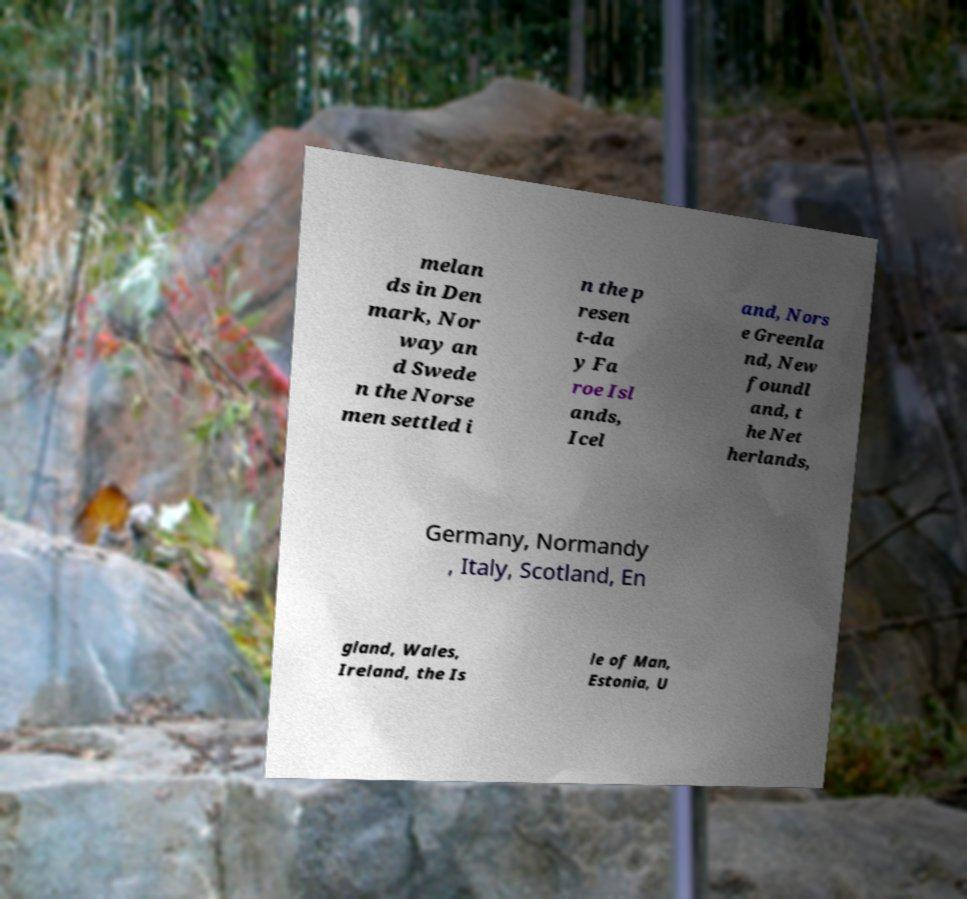Can you accurately transcribe the text from the provided image for me? melan ds in Den mark, Nor way an d Swede n the Norse men settled i n the p resen t-da y Fa roe Isl ands, Icel and, Nors e Greenla nd, New foundl and, t he Net herlands, Germany, Normandy , Italy, Scotland, En gland, Wales, Ireland, the Is le of Man, Estonia, U 